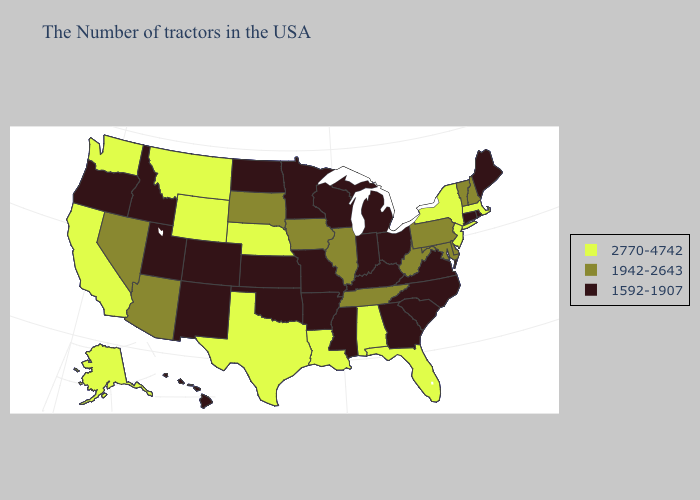Name the states that have a value in the range 2770-4742?
Be succinct. Massachusetts, New York, New Jersey, Florida, Alabama, Louisiana, Nebraska, Texas, Wyoming, Montana, California, Washington, Alaska. Name the states that have a value in the range 1592-1907?
Be succinct. Maine, Rhode Island, Connecticut, Virginia, North Carolina, South Carolina, Ohio, Georgia, Michigan, Kentucky, Indiana, Wisconsin, Mississippi, Missouri, Arkansas, Minnesota, Kansas, Oklahoma, North Dakota, Colorado, New Mexico, Utah, Idaho, Oregon, Hawaii. What is the lowest value in states that border Minnesota?
Give a very brief answer. 1592-1907. What is the highest value in states that border Louisiana?
Be succinct. 2770-4742. Name the states that have a value in the range 2770-4742?
Concise answer only. Massachusetts, New York, New Jersey, Florida, Alabama, Louisiana, Nebraska, Texas, Wyoming, Montana, California, Washington, Alaska. Does New York have the highest value in the Northeast?
Give a very brief answer. Yes. Name the states that have a value in the range 1942-2643?
Be succinct. New Hampshire, Vermont, Delaware, Maryland, Pennsylvania, West Virginia, Tennessee, Illinois, Iowa, South Dakota, Arizona, Nevada. Does Massachusetts have the lowest value in the USA?
Give a very brief answer. No. What is the lowest value in the Northeast?
Quick response, please. 1592-1907. Does New Hampshire have the lowest value in the USA?
Give a very brief answer. No. Name the states that have a value in the range 1942-2643?
Concise answer only. New Hampshire, Vermont, Delaware, Maryland, Pennsylvania, West Virginia, Tennessee, Illinois, Iowa, South Dakota, Arizona, Nevada. Does North Dakota have a higher value than Vermont?
Answer briefly. No. What is the highest value in the Northeast ?
Keep it brief. 2770-4742. Name the states that have a value in the range 2770-4742?
Short answer required. Massachusetts, New York, New Jersey, Florida, Alabama, Louisiana, Nebraska, Texas, Wyoming, Montana, California, Washington, Alaska. Does Georgia have a higher value than Pennsylvania?
Answer briefly. No. 